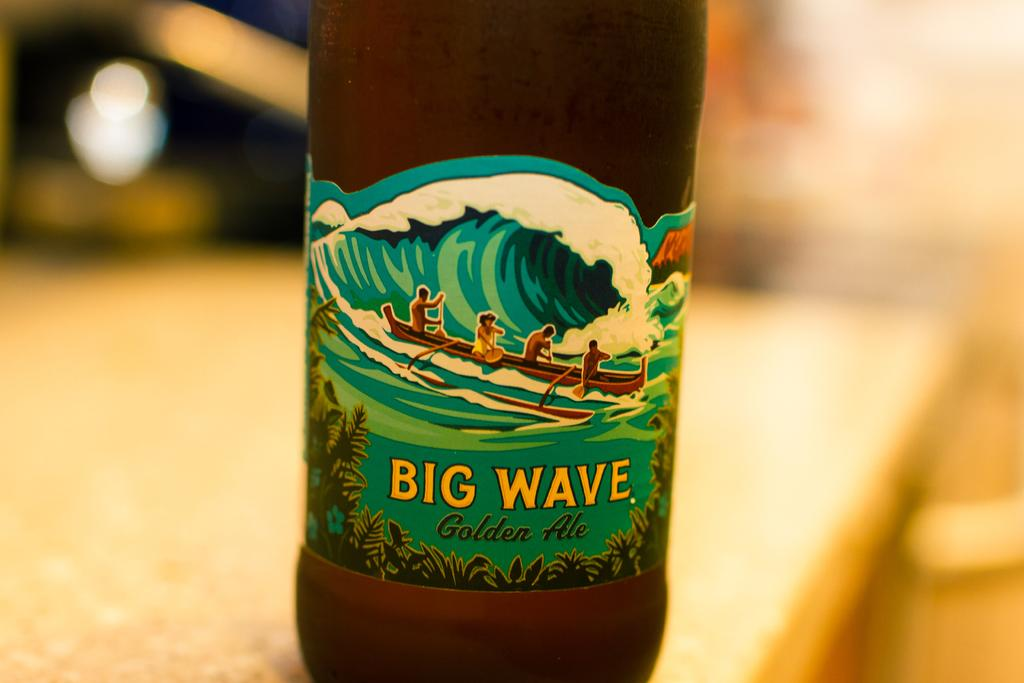<image>
Create a compact narrative representing the image presented. The label for Big Wave Golden Ale includes people in a kayak. 